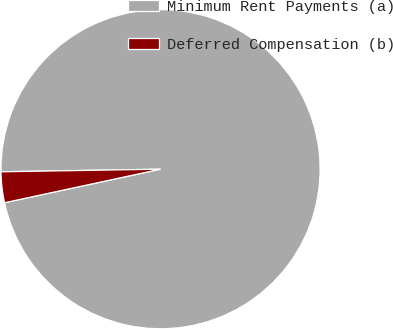<chart> <loc_0><loc_0><loc_500><loc_500><pie_chart><fcel>Minimum Rent Payments (a)<fcel>Deferred Compensation (b)<nl><fcel>96.89%<fcel>3.11%<nl></chart> 